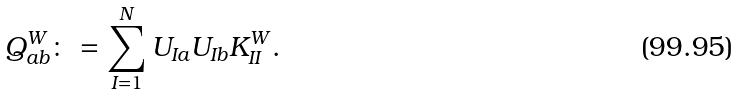<formula> <loc_0><loc_0><loc_500><loc_500>Q _ { a b } ^ { W } \colon = \sum _ { I = 1 } ^ { N } U _ { I a } U _ { I b } K _ { I I } ^ { W } .</formula> 